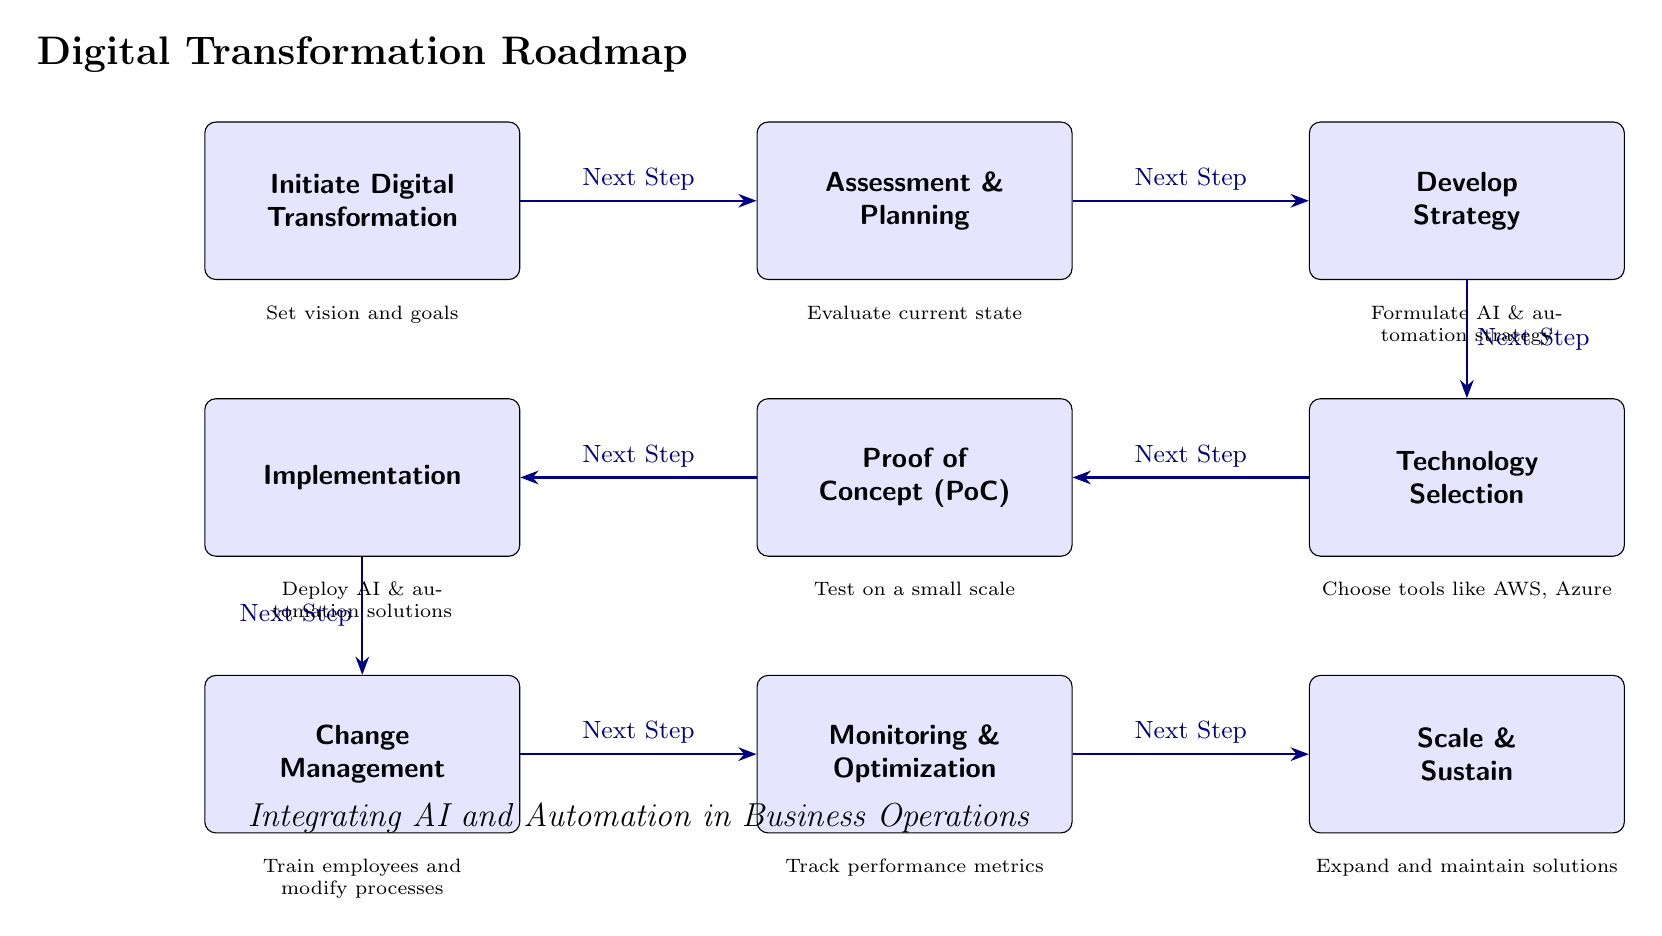What is the first step in the Digital Transformation Roadmap? The first node in the diagram represents the initial step in the process, labeled "Initiate Digital Transformation."
Answer: Initiate Digital Transformation How many main steps are represented in the diagram? By counting the boxes in the main sequence from "Initiate Digital Transformation" to "Scale & Sustain," we find there are nine distinct steps.
Answer: Nine What does the node "Technology Selection" immediately follow? The diagram shows the flow from "Develop Strategy," directly leading into "Technology Selection," illustrating the order of events.
Answer: Develop Strategy What is the purpose of the "Monitoring & Optimization" step? The text associated with the "Monitoring & Optimization" step indicates that it is focused on tracking performance metrics, indicating its role in ensuring that implemented solutions work effectively.
Answer: Track performance metrics Which step requires training employees? The relevant step is "Change Management," where the focus is on training employees and modifying processes to adapt to new technology.
Answer: Change Management Which two steps are directly involved after "Proof of Concept (PoC)"? "Implementation" follows "Proof of Concept (PoC)" directly, as indicated in the sequence, followed by "Change Management," which is the next step after "Implementation."
Answer: Implementation, Change Management How does the "Assessment & Planning" step contribute to the overall process? It evaluates the current state of the business, setting the foundation for decisions made in subsequent steps of the digital transformation process.
Answer: Evaluate current state Is "Scale & Sustain" the final step in the roadmap? Yes, "Scale & Sustain" is clearly depicted as the last node, marking the conclusion of the sequence of steps outlined in the diagram.
Answer: Yes What is the focus of the "Develop Strategy" step? The "Develop Strategy" step emphasizes the formulation of AI and automation strategies, which guides the technological decisions in the following phases.
Answer: Formulate AI & automation strategy 